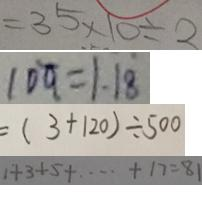<formula> <loc_0><loc_0><loc_500><loc_500>= 3 5 \times 1 0 \div 2 
 1 0 q = 1 . 1 8 
 = ( 3 + 1 2 0 ) \div 5 0 0 
 1 + 3 + 5 + \cdots + 1 7 = 8 1</formula> 